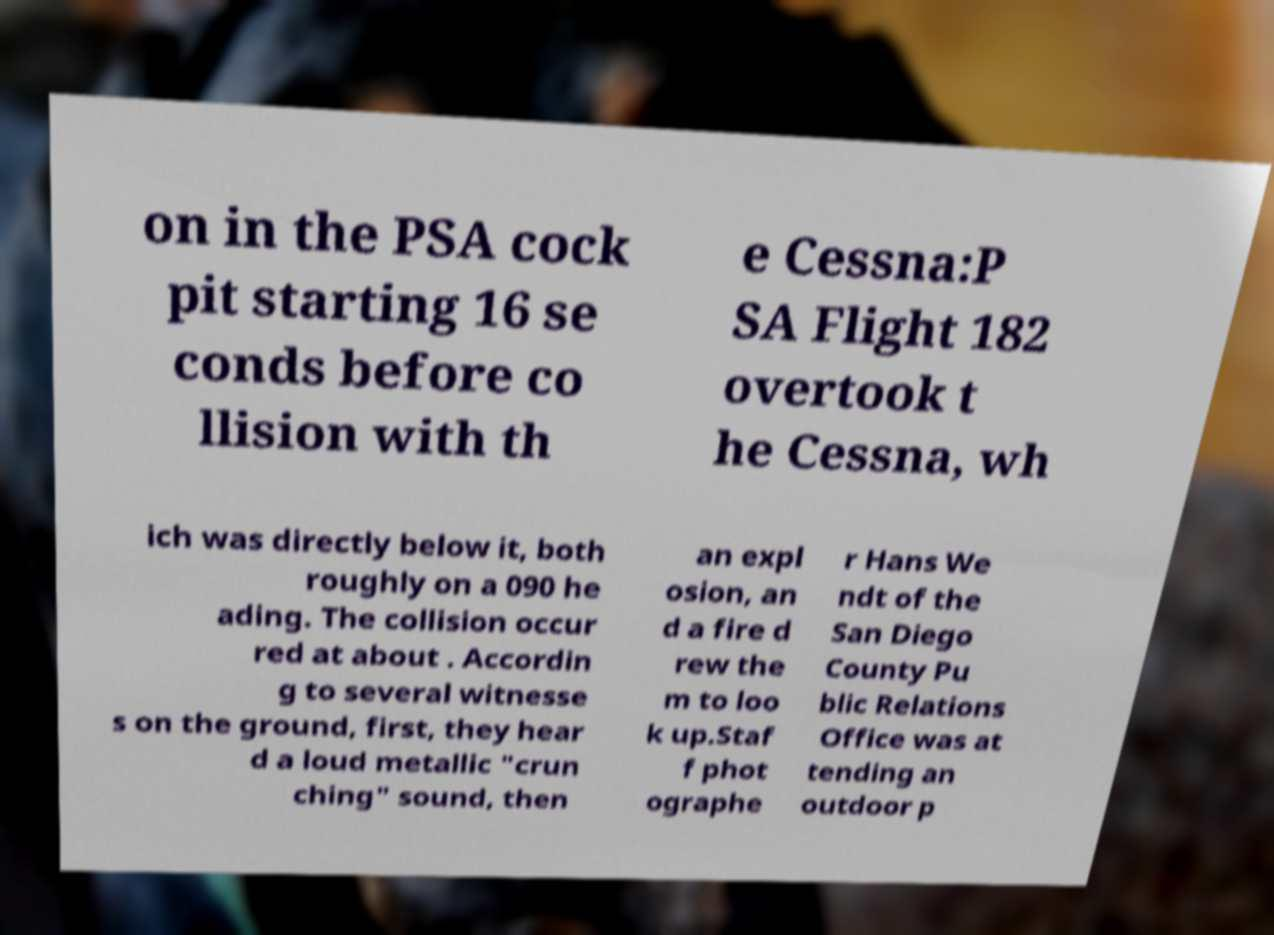Could you assist in decoding the text presented in this image and type it out clearly? on in the PSA cock pit starting 16 se conds before co llision with th e Cessna:P SA Flight 182 overtook t he Cessna, wh ich was directly below it, both roughly on a 090 he ading. The collision occur red at about . Accordin g to several witnesse s on the ground, first, they hear d a loud metallic "crun ching" sound, then an expl osion, an d a fire d rew the m to loo k up.Staf f phot ographe r Hans We ndt of the San Diego County Pu blic Relations Office was at tending an outdoor p 